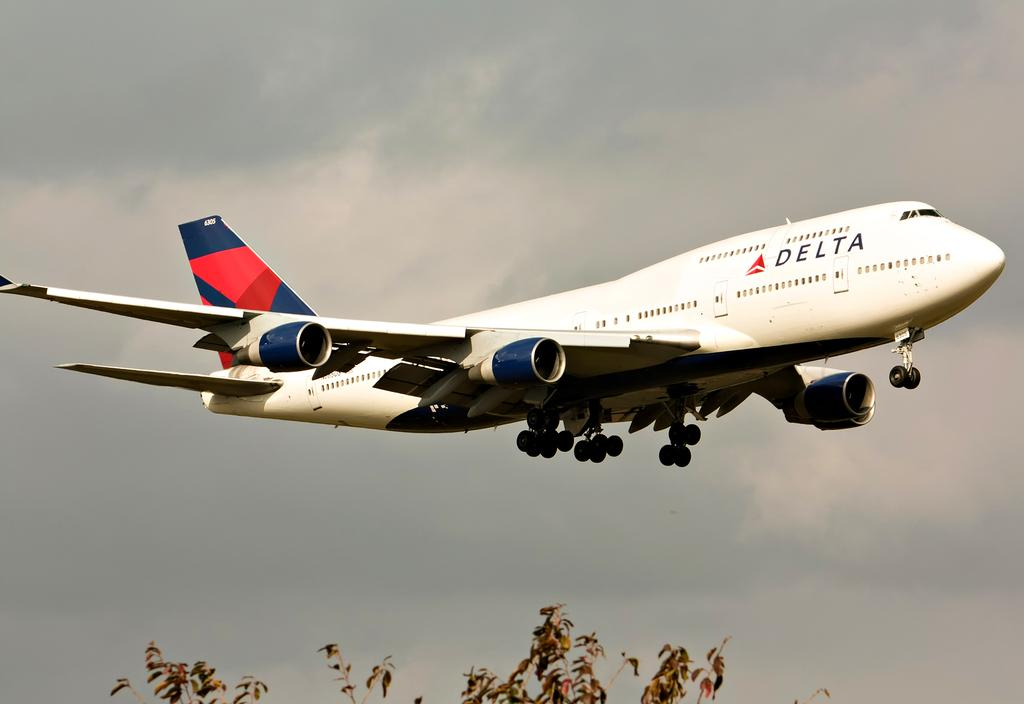<image>
Create a compact narrative representing the image presented. A white Delta plane travels through the sky. 